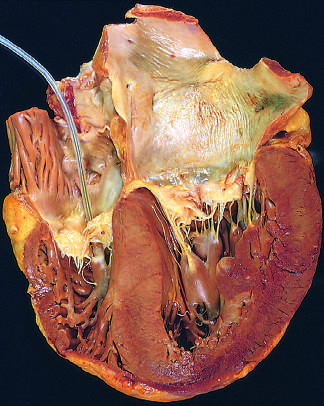s a pacemaker presented incidentally in the right ventricle?
Answer the question using a single word or phrase. Yes 